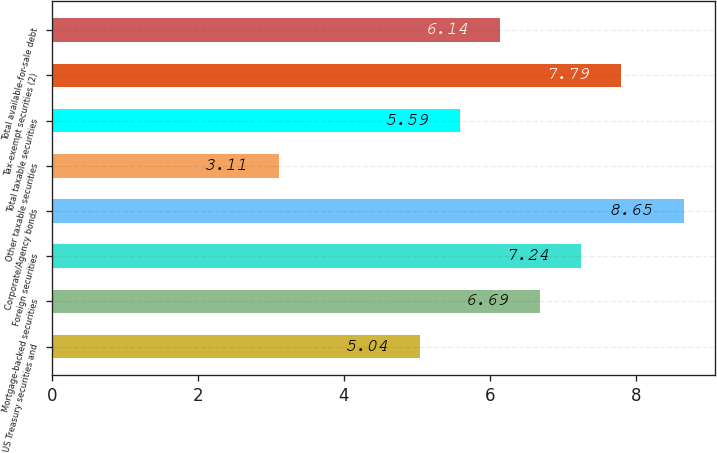Convert chart to OTSL. <chart><loc_0><loc_0><loc_500><loc_500><bar_chart><fcel>US Treasury securities and<fcel>Mortgage-backed securities<fcel>Foreign securities<fcel>Corporate/Agency bonds<fcel>Other taxable securities<fcel>Total taxable securities<fcel>Tax-exempt securities (2)<fcel>Total available-for-sale debt<nl><fcel>5.04<fcel>6.69<fcel>7.24<fcel>8.65<fcel>3.11<fcel>5.59<fcel>7.79<fcel>6.14<nl></chart> 